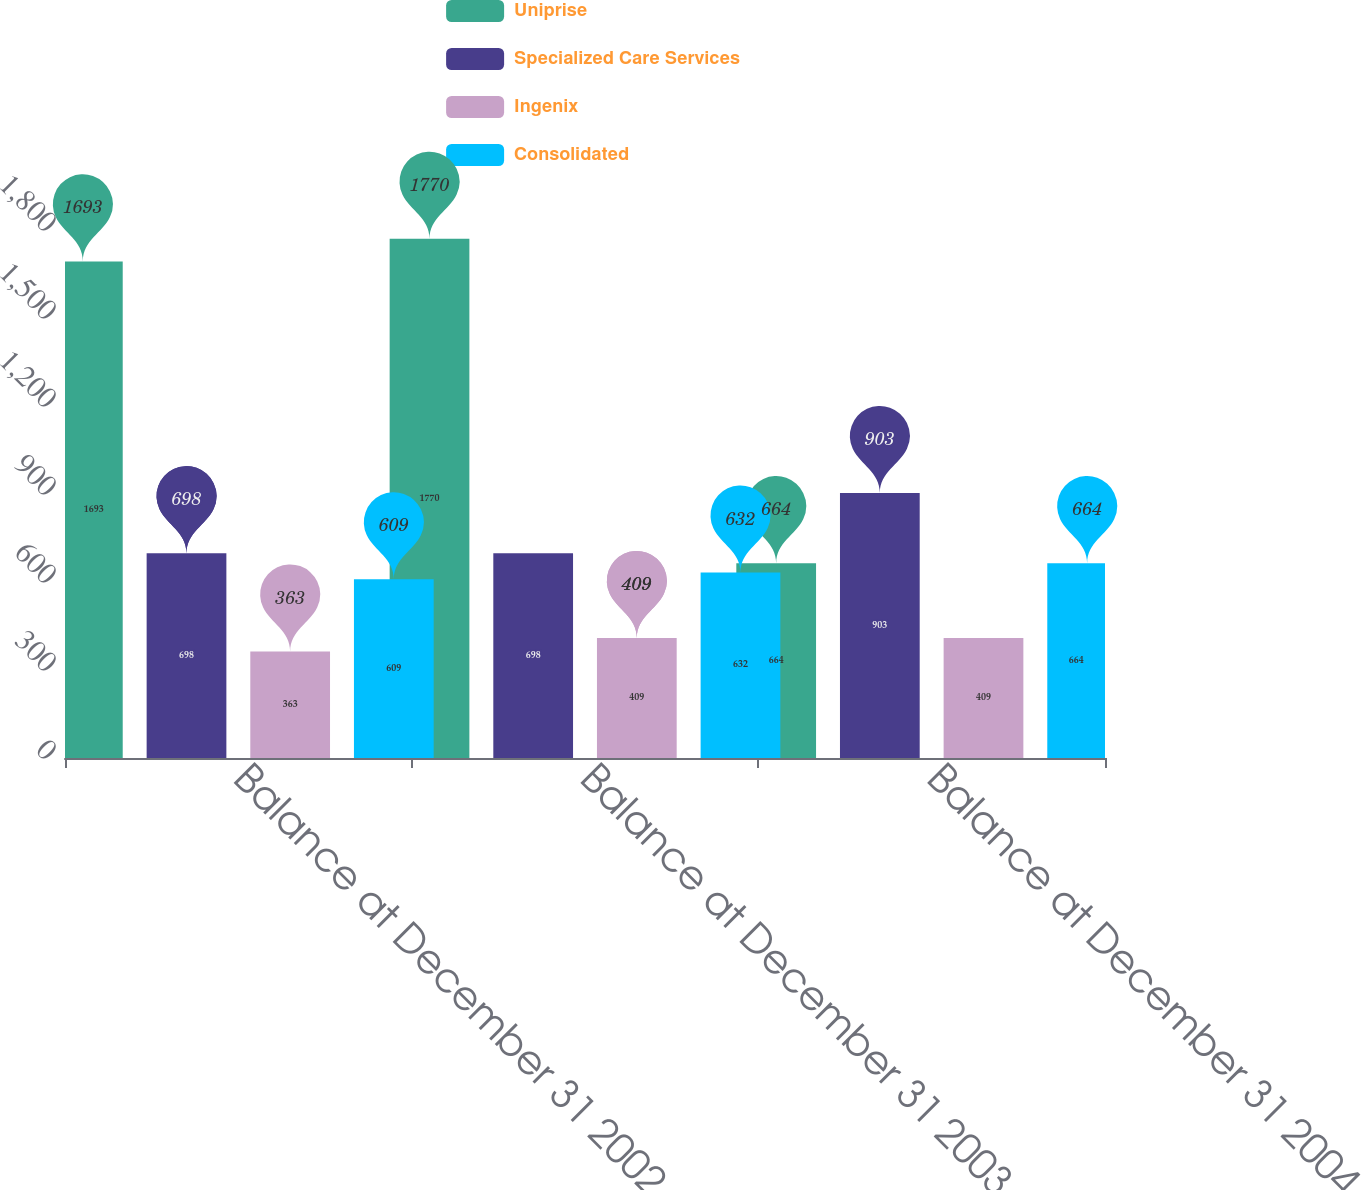Convert chart. <chart><loc_0><loc_0><loc_500><loc_500><stacked_bar_chart><ecel><fcel>Balance at December 31 2002<fcel>Balance at December 31 2003<fcel>Balance at December 31 2004<nl><fcel>Uniprise<fcel>1693<fcel>1770<fcel>664<nl><fcel>Specialized Care Services<fcel>698<fcel>698<fcel>903<nl><fcel>Ingenix<fcel>363<fcel>409<fcel>409<nl><fcel>Consolidated<fcel>609<fcel>632<fcel>664<nl></chart> 